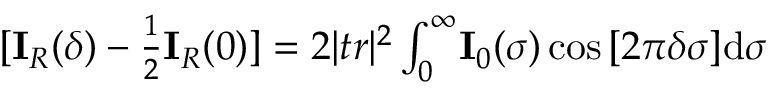<formula> <loc_0><loc_0><loc_500><loc_500>\begin{array} { r } { [ I _ { R } ( \delta ) - \frac { 1 } { 2 } I _ { R } ( 0 ) ] = 2 | t r | ^ { 2 } \int _ { 0 } ^ { \infty } \, I _ { 0 } ( \sigma ) \cos { [ 2 \pi \delta \sigma ] } d \sigma } \end{array}</formula> 